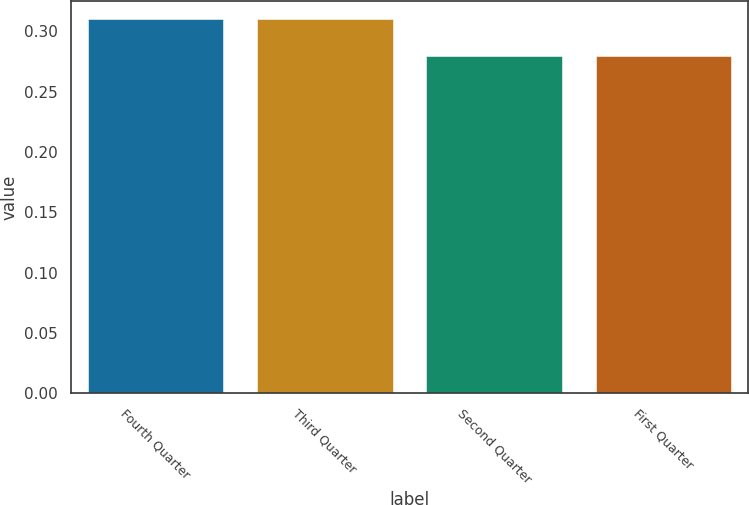Convert chart. <chart><loc_0><loc_0><loc_500><loc_500><bar_chart><fcel>Fourth Quarter<fcel>Third Quarter<fcel>Second Quarter<fcel>First Quarter<nl><fcel>0.31<fcel>0.31<fcel>0.28<fcel>0.28<nl></chart> 